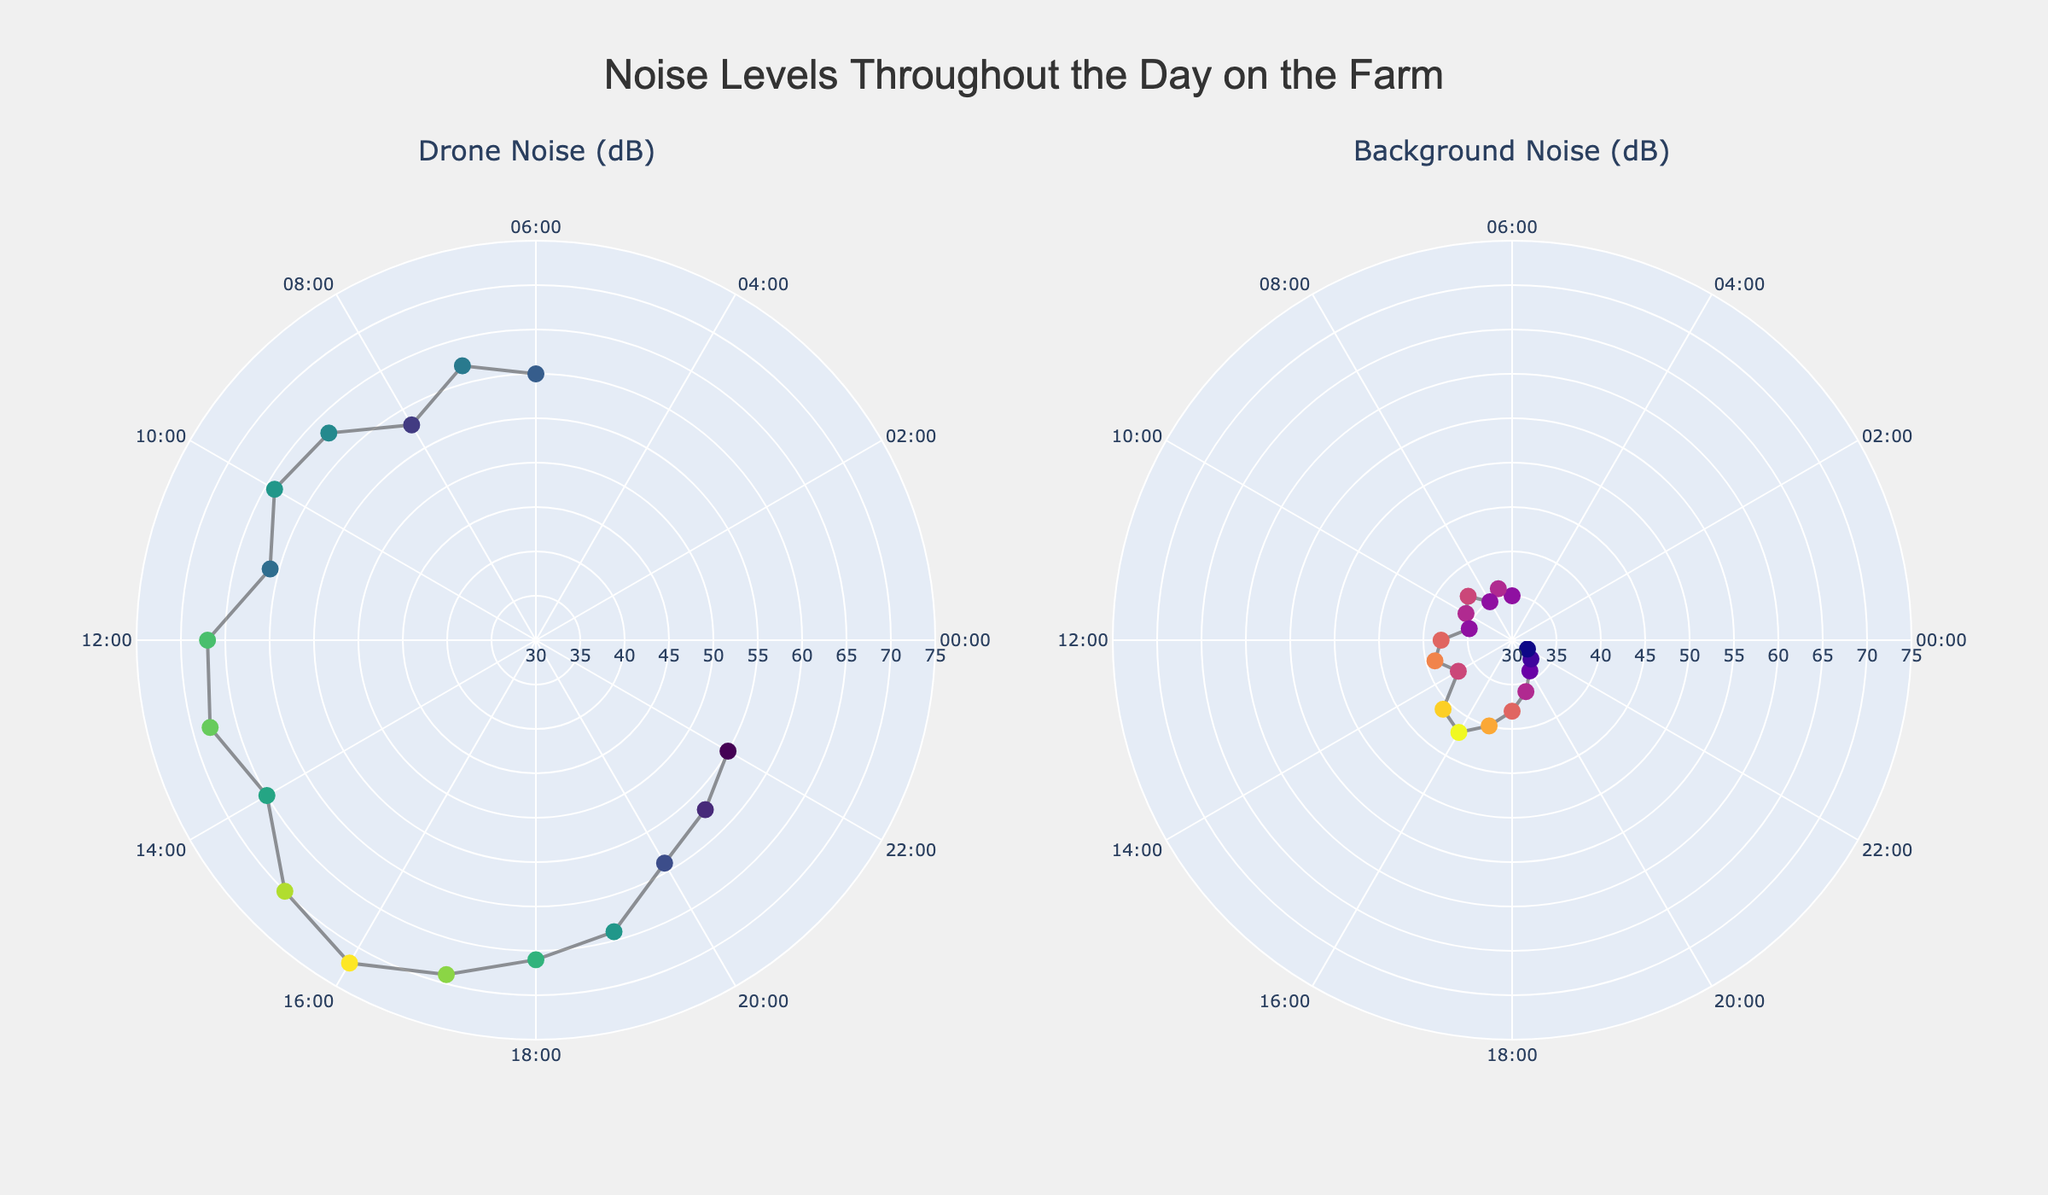What's the highest drone noise level throughout the day? The highest drone noise level can be identified by looking at the peak value in the drone noise subplot. The maximum value of the radius in the plot indicates the highest noise level.
Answer: 72 dB At what time does the background noise level reach its peak? To find the peak background noise level, look at the highest point in the background noise subplot and reference the corresponding time on the angular axis.
Answer: 16:00 How do the noise levels at 6:00 compare between drones and the background? Compare the radius values at the 6:00 position in both subplots. The drone noise is higher than the background noise.
Answer: Drone: 60 dB, Background: 35 dB Which hour has the most significant difference between drone noise and background noise? To determine the hour with the most significant difference, calculate the differences between drone noise and background noise at each hour, and identify the maximum difference. The greatest difference is between 6:00 and 15:00.
Answer: 15:00 Is there a time of day when the drone noise levels decrease significantly? Observe the trend in the drone noise subplot by looking for a noticeable drop in noise levels over time. The drone noise decreases significantly from 19:00 onwards.
Answer: Yes, from 19:00 onwards During what hours is the background noise the lowest? Look for the minimum values on the radius of the background noise subplot and reference the corresponding times on the angular axis. The lowest background noise is around 21:00 and 22:00.
Answer: 21:00 and 22:00 What is the difference in drone noise levels between the peak and the time with the lowest noise level? Identify the peak and lowest noise levels in the drone noise subplot (peak at 72 dB at 16:00 and lowest at 55 dB at 22:00), then calculate the difference.
Answer: 72 - 55 = 17 dB Is there a noticeable pattern in how drone noise varies throughout the day? A noticeable pattern can be observed by analyzing the trend in the drone noise subplot. For example, there is a general increase in drone noise during daylight hours and a decrease toward the evening.
Answer: Yes, it peaks in the afternoon and decreases in the evening Do the drone and background noise levels follow a similar pattern? Compare the overall shape and trend of both subplots. The drone noise levels generally follow an increasing trend during the day and decrease in the evening, while background noise levels remain more stable with slight increases in the afternoon.
Answer: No, drone noise levels vary more significantly How does the drone noise level at 10:00 compare to that at 20:00? Compare the radius values for the drone noise at 10:00 and 20:00 on the drone noise subplot. The level at 10:00 is higher than at 20:00.
Answer: 10:00: 64 dB, 20:00: 59 dB 